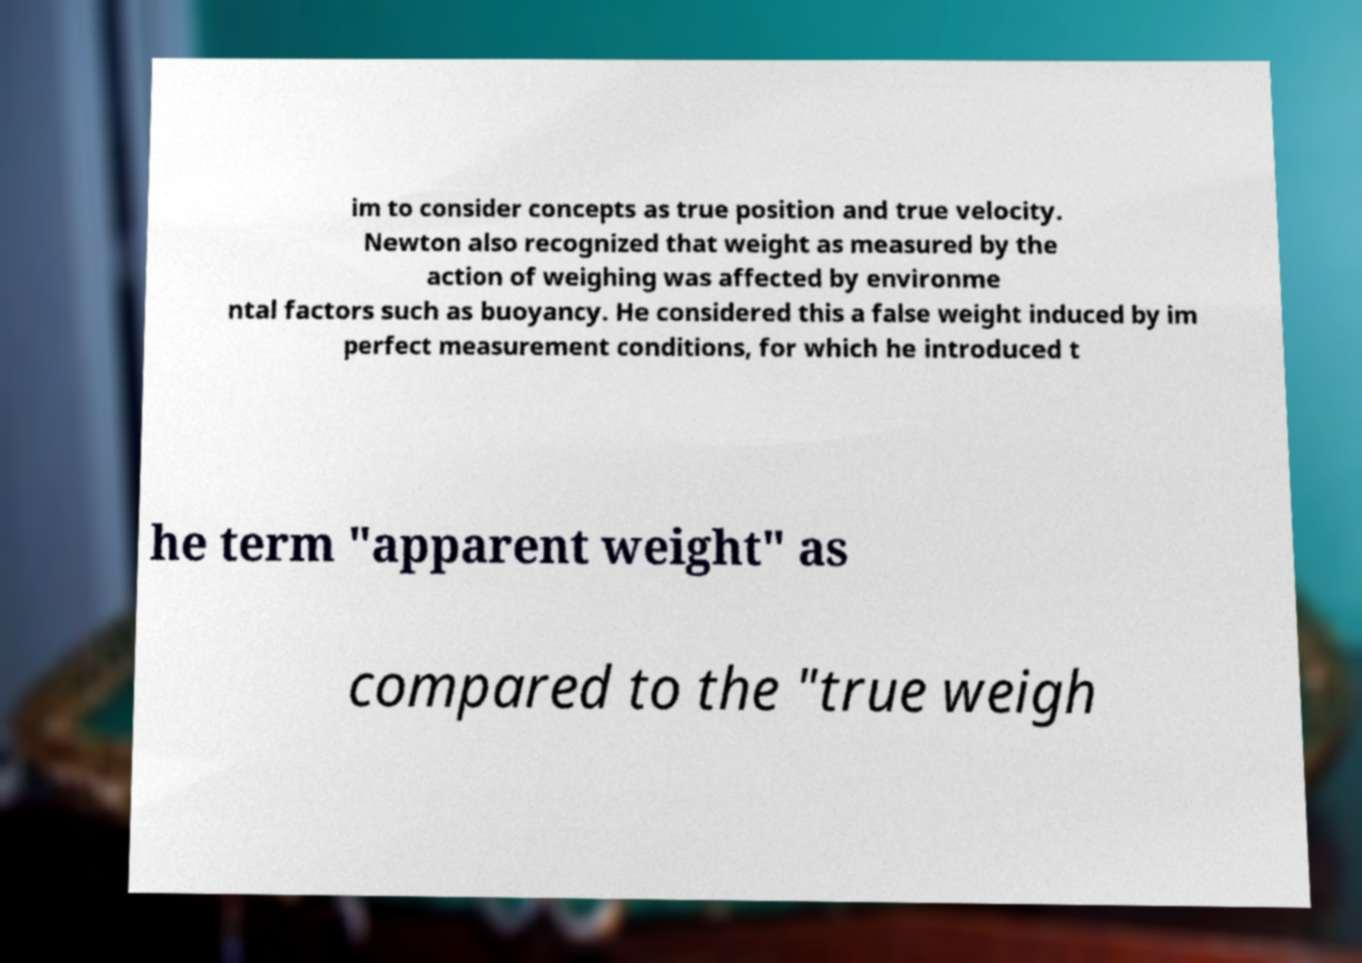Could you extract and type out the text from this image? im to consider concepts as true position and true velocity. Newton also recognized that weight as measured by the action of weighing was affected by environme ntal factors such as buoyancy. He considered this a false weight induced by im perfect measurement conditions, for which he introduced t he term "apparent weight" as compared to the "true weigh 